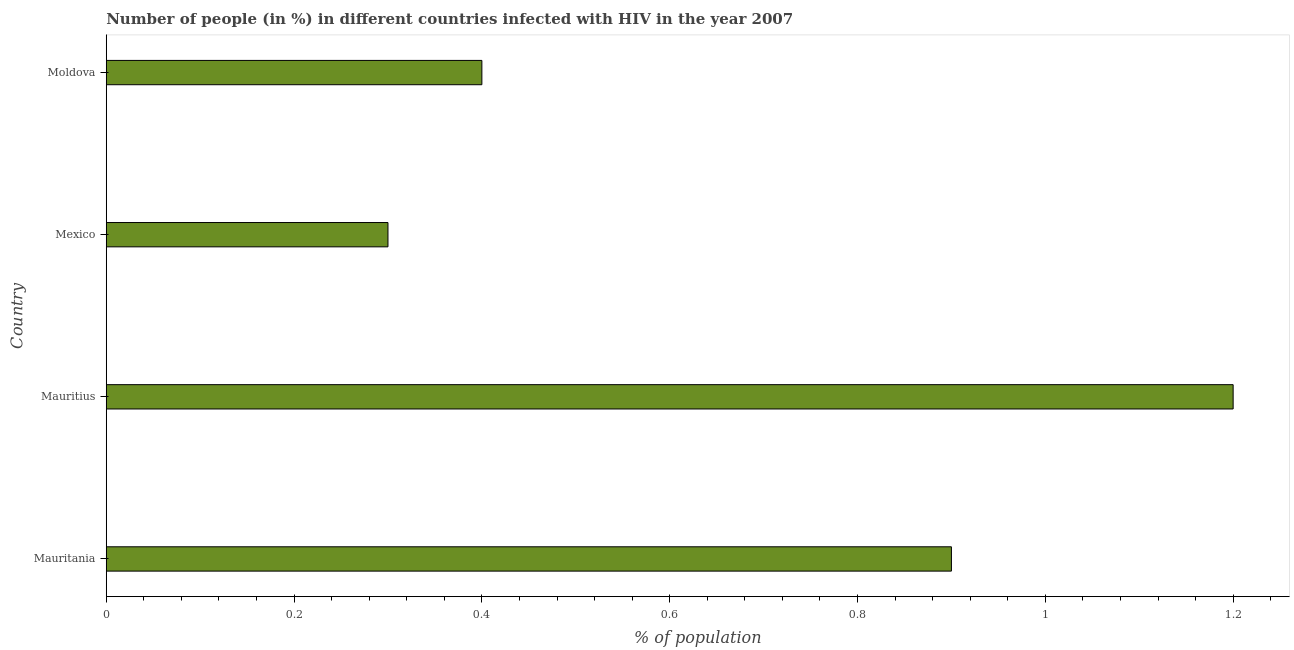Does the graph contain any zero values?
Offer a very short reply. No. Does the graph contain grids?
Provide a succinct answer. No. What is the title of the graph?
Make the answer very short. Number of people (in %) in different countries infected with HIV in the year 2007. What is the label or title of the X-axis?
Give a very brief answer. % of population. What is the number of people infected with hiv in Mexico?
Give a very brief answer. 0.3. Across all countries, what is the minimum number of people infected with hiv?
Provide a succinct answer. 0.3. In which country was the number of people infected with hiv maximum?
Ensure brevity in your answer.  Mauritius. In which country was the number of people infected with hiv minimum?
Make the answer very short. Mexico. What is the average number of people infected with hiv per country?
Provide a succinct answer. 0.7. What is the median number of people infected with hiv?
Your answer should be compact. 0.65. What is the ratio of the number of people infected with hiv in Mauritius to that in Mexico?
Provide a succinct answer. 4. What is the difference between the highest and the second highest number of people infected with hiv?
Offer a terse response. 0.3. What is the difference between the highest and the lowest number of people infected with hiv?
Offer a terse response. 0.9. In how many countries, is the number of people infected with hiv greater than the average number of people infected with hiv taken over all countries?
Ensure brevity in your answer.  2. How many bars are there?
Provide a succinct answer. 4. What is the difference between two consecutive major ticks on the X-axis?
Your answer should be very brief. 0.2. Are the values on the major ticks of X-axis written in scientific E-notation?
Provide a short and direct response. No. What is the % of population in Mauritius?
Provide a short and direct response. 1.2. What is the % of population in Mexico?
Provide a short and direct response. 0.3. What is the % of population of Moldova?
Provide a succinct answer. 0.4. What is the difference between the % of population in Mauritania and Moldova?
Your response must be concise. 0.5. What is the difference between the % of population in Mauritius and Moldova?
Your response must be concise. 0.8. What is the difference between the % of population in Mexico and Moldova?
Give a very brief answer. -0.1. What is the ratio of the % of population in Mauritania to that in Moldova?
Keep it short and to the point. 2.25. 